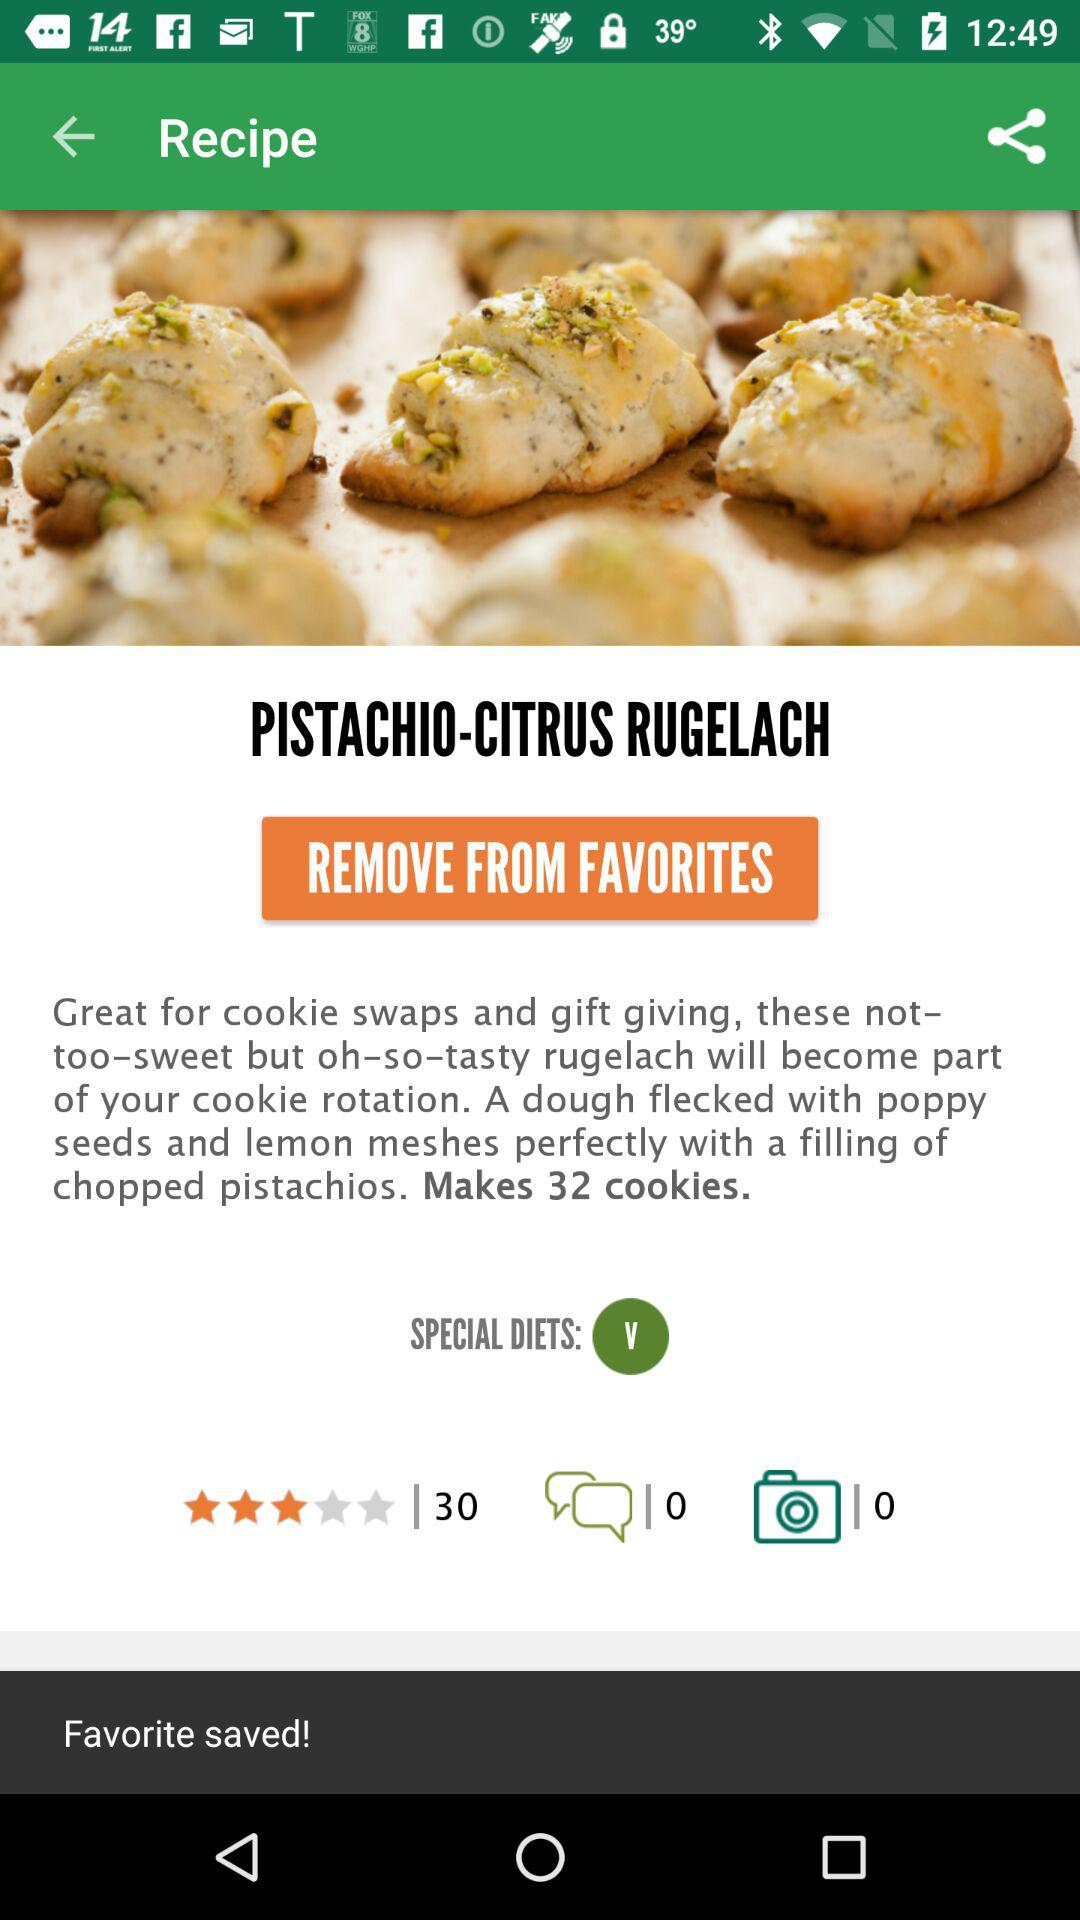What is the cookie name? The cookie name is "PISTACHIO-CITRUS RUGELACH". 